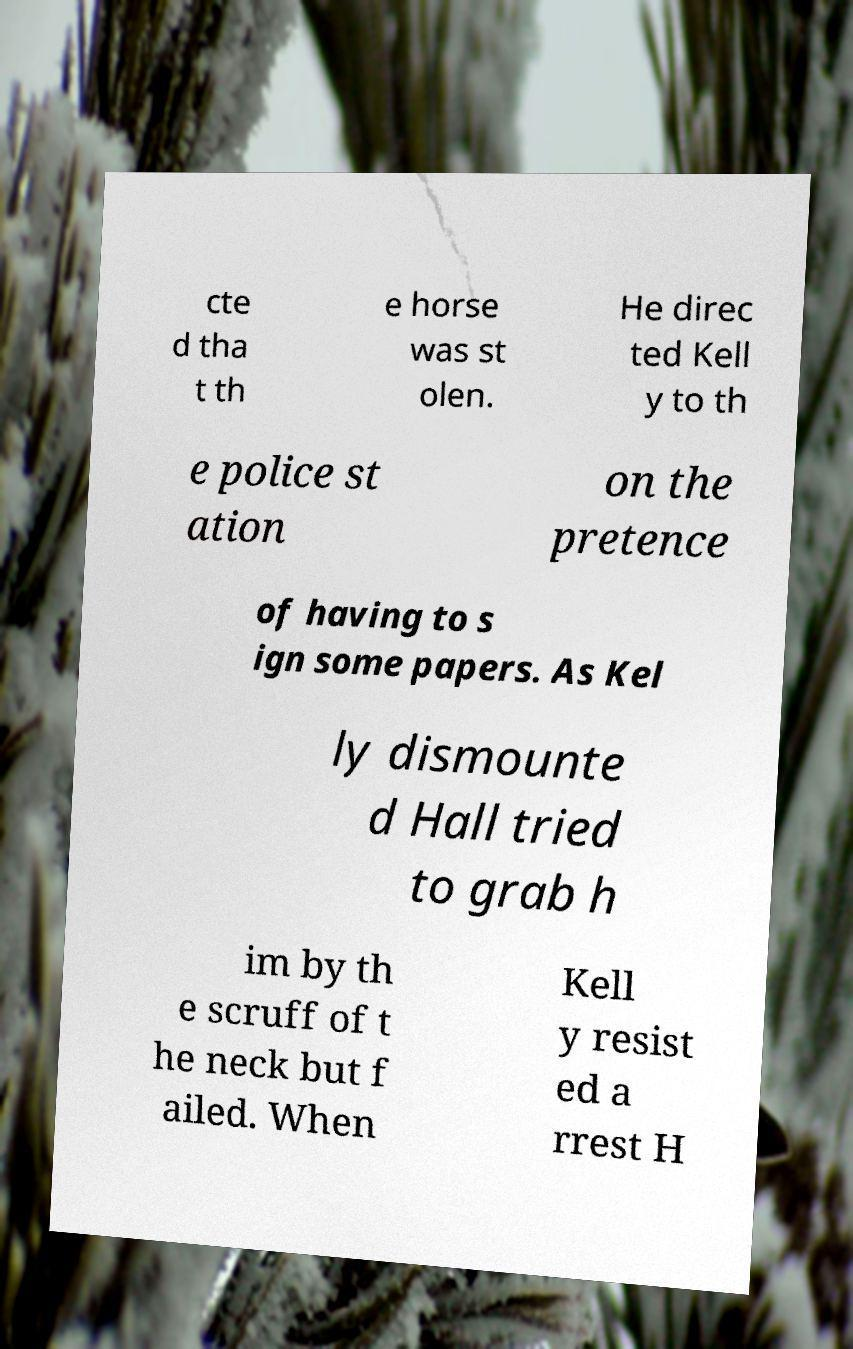For documentation purposes, I need the text within this image transcribed. Could you provide that? cte d tha t th e horse was st olen. He direc ted Kell y to th e police st ation on the pretence of having to s ign some papers. As Kel ly dismounte d Hall tried to grab h im by th e scruff of t he neck but f ailed. When Kell y resist ed a rrest H 